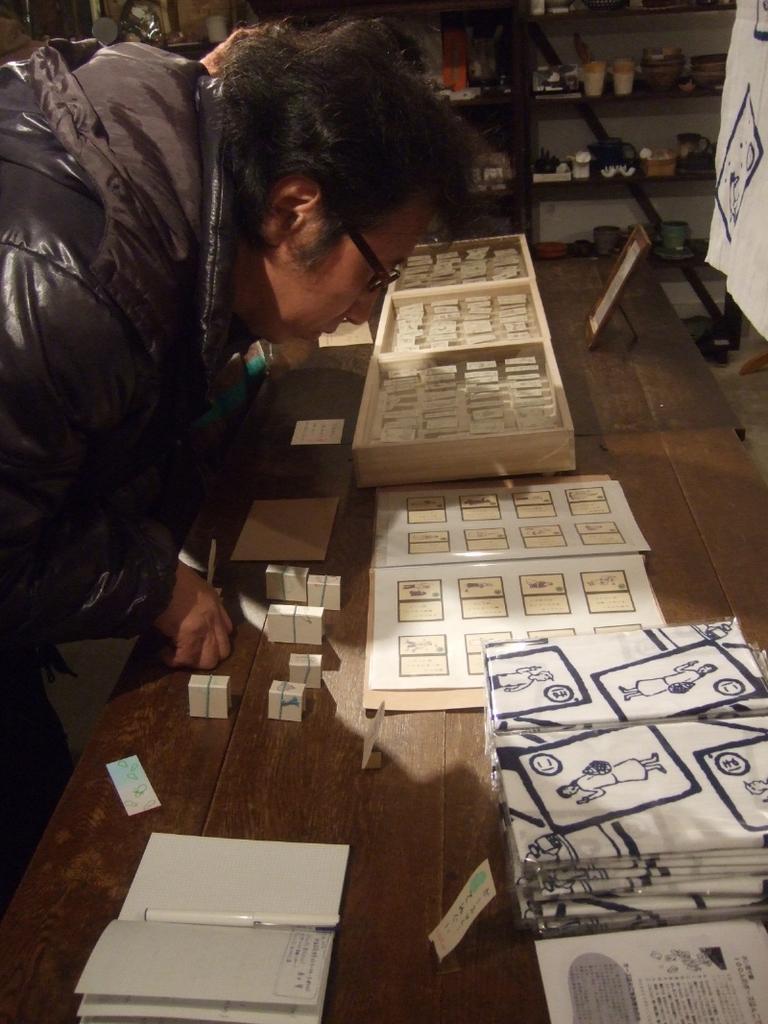Could you give a brief overview of what you see in this image? In this picture we can see a man, in front of him we can see tables, on these tables we can see some objects and in the background we can see racks and some objects. 